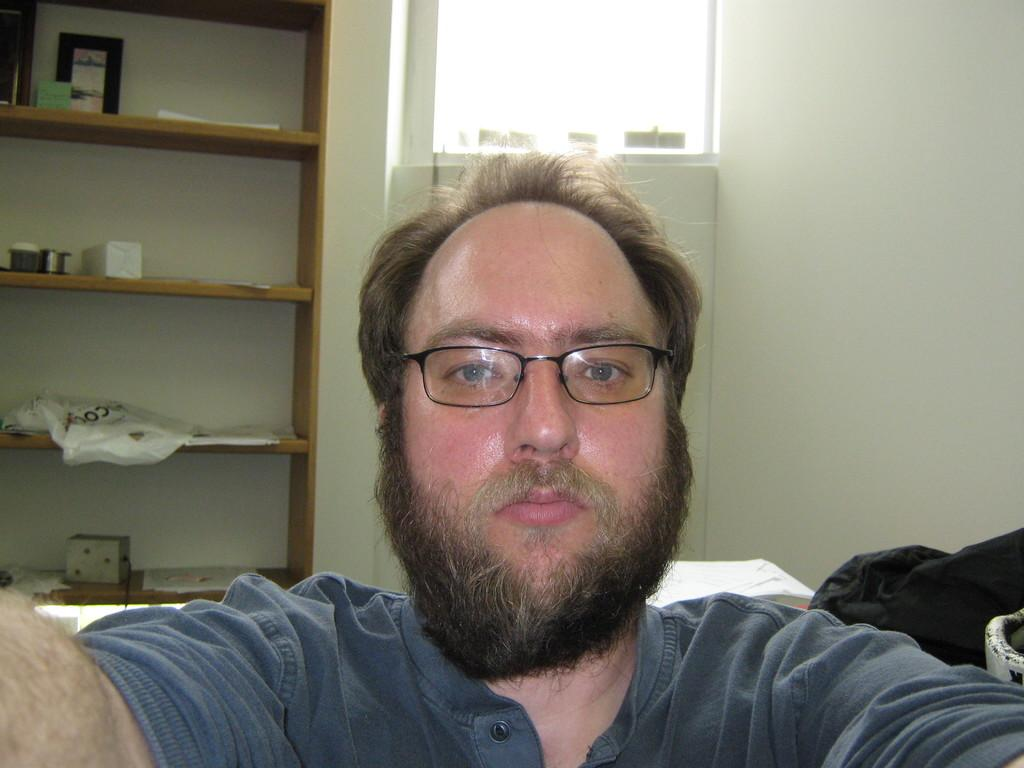Who or what is present in the image? There is a person in the image. What is the person wearing? The person is wearing a gray shirt. What can be seen in the background of the image? There are objects on racks in the background of the image, and the wall is white. Is there any fuel visible in the image? No, there is no fuel present in the image. Can you see a playground in the background of the image? No, there is no playground visible in the image. 